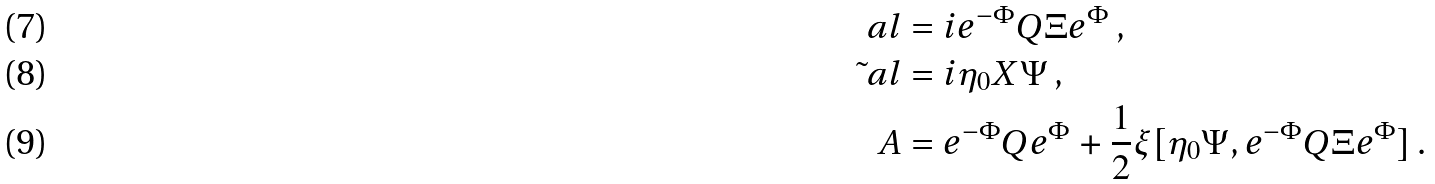<formula> <loc_0><loc_0><loc_500><loc_500>\ a l & = i e ^ { - \Phi } Q \Xi e ^ { \Phi } \, , \\ \tilde { \ } a l & = i \eta _ { 0 } X \Psi \, , \\ A & = e ^ { - \Phi } Q e ^ { \Phi } + \frac { 1 } { 2 } \xi [ \eta _ { 0 } \Psi , e ^ { - \Phi } Q \Xi e ^ { \Phi } ] \, .</formula> 